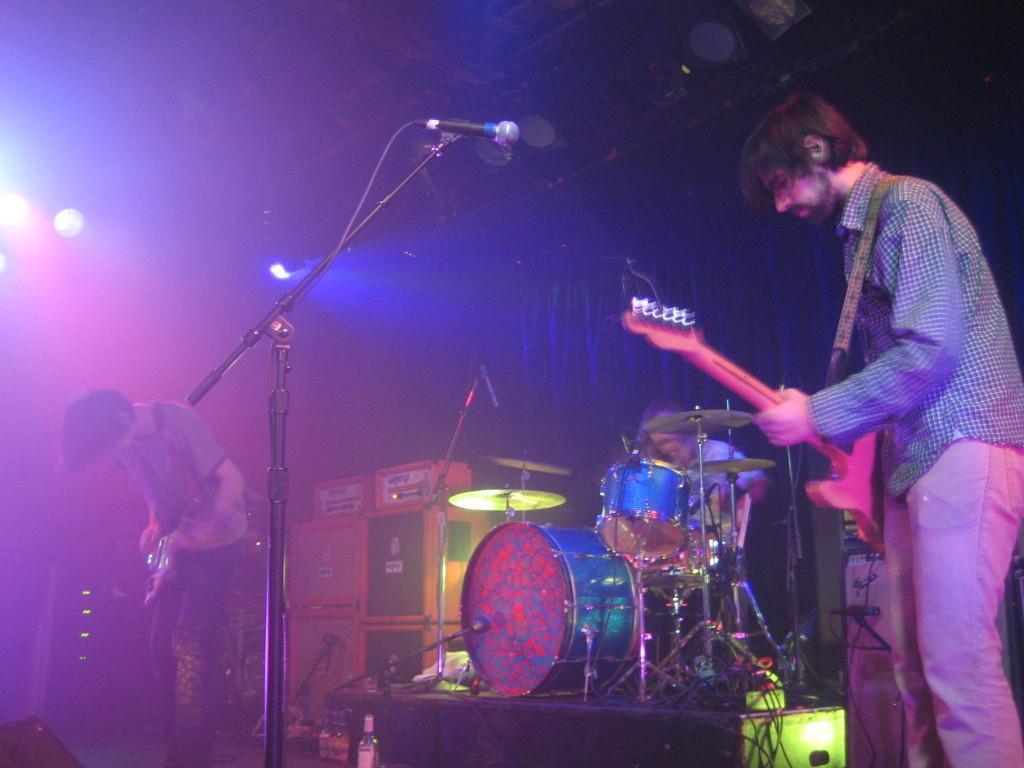How would you summarize this image in a sentence or two? In this there are three people, two people and standing and playing guitar and one is sitting and playing drums. At the back there is a curtain and in the middle of the image there are microphones, drums, wires and bottles. 